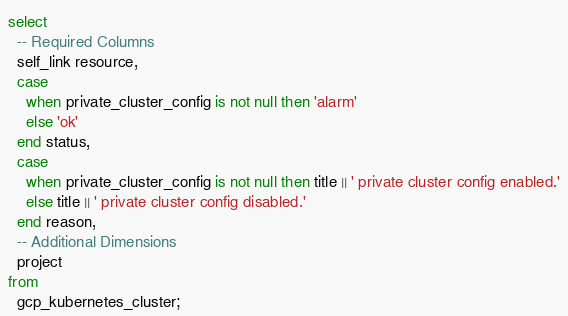<code> <loc_0><loc_0><loc_500><loc_500><_SQL_>select
  -- Required Columns
  self_link resource,
  case
    when private_cluster_config is not null then 'alarm'
    else 'ok'
  end status,
  case
    when private_cluster_config is not null then title || ' private cluster config enabled.'
    else title || ' private cluster config disabled.'
  end reason,
  -- Additional Dimensions
  project
from
  gcp_kubernetes_cluster;</code> 